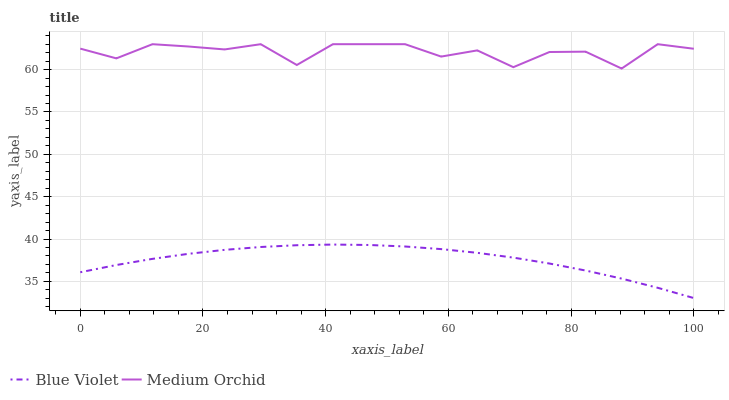Does Blue Violet have the minimum area under the curve?
Answer yes or no. Yes. Does Medium Orchid have the maximum area under the curve?
Answer yes or no. Yes. Does Blue Violet have the maximum area under the curve?
Answer yes or no. No. Is Blue Violet the smoothest?
Answer yes or no. Yes. Is Medium Orchid the roughest?
Answer yes or no. Yes. Is Blue Violet the roughest?
Answer yes or no. No. Does Medium Orchid have the highest value?
Answer yes or no. Yes. Does Blue Violet have the highest value?
Answer yes or no. No. Is Blue Violet less than Medium Orchid?
Answer yes or no. Yes. Is Medium Orchid greater than Blue Violet?
Answer yes or no. Yes. Does Blue Violet intersect Medium Orchid?
Answer yes or no. No. 